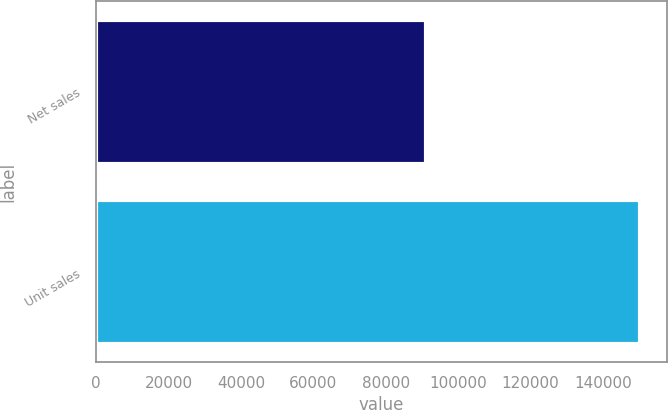<chart> <loc_0><loc_0><loc_500><loc_500><bar_chart><fcel>Net sales<fcel>Unit sales<nl><fcel>91279<fcel>150257<nl></chart> 